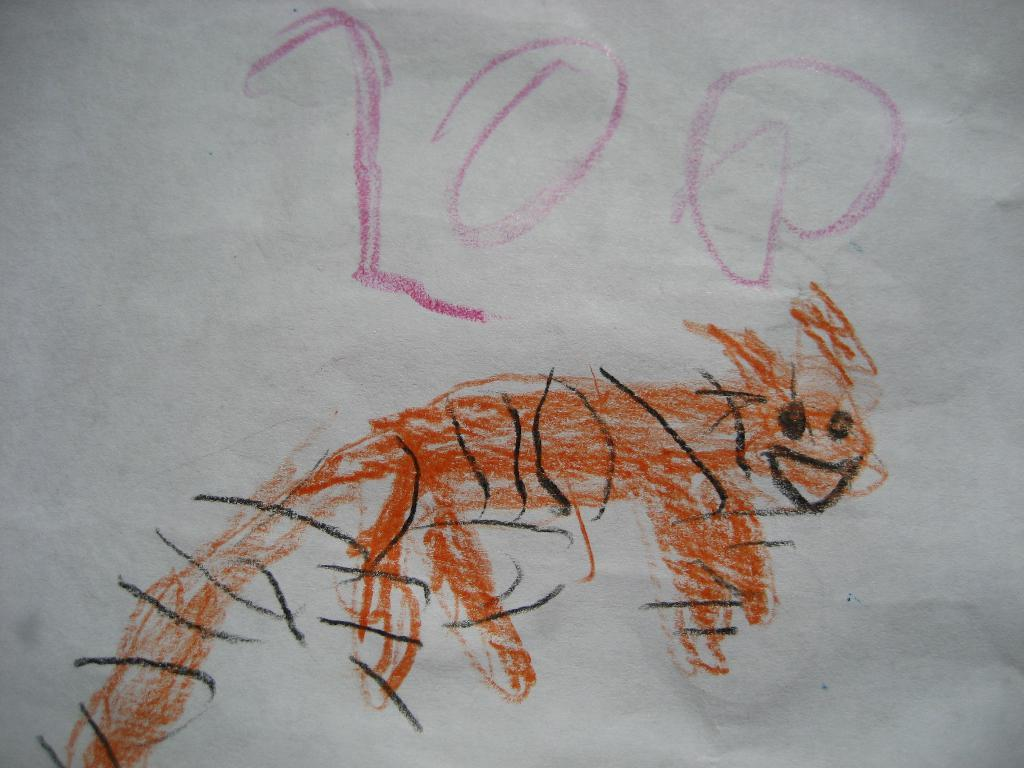What is depicted on the white surface in the image? There is a drawing present on a white surface in the image. What type of drain is visible in the image? There is no drain present in the image; it only features a drawing on a white surface. What letter can be seen in the drawing in the image? The provided facts do not mention any specific details about the drawing, such as the presence of a letter. 